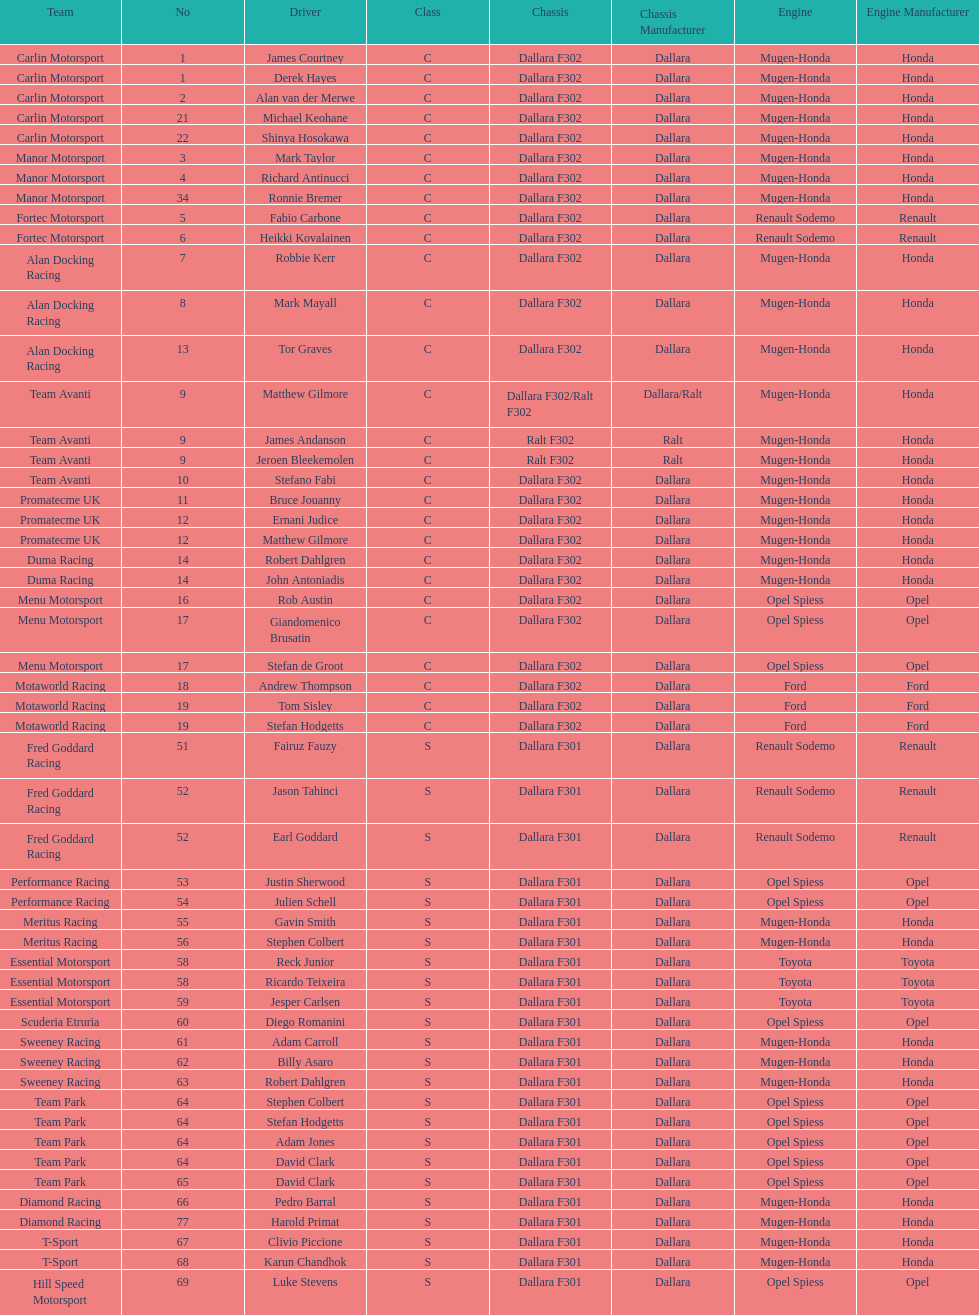What team is listed above diamond racing? Team Park. 